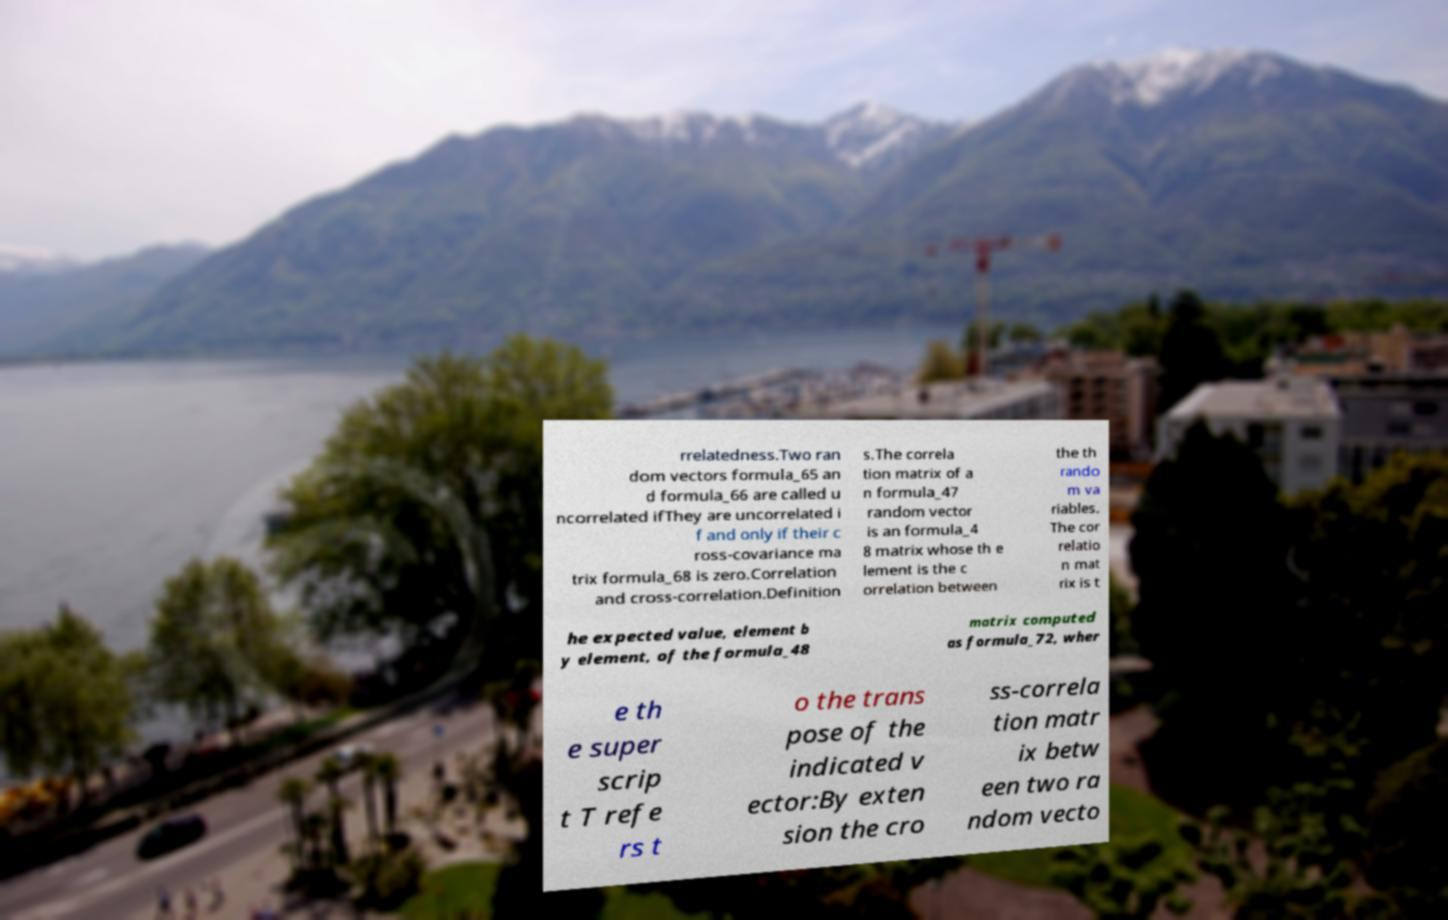Can you read and provide the text displayed in the image?This photo seems to have some interesting text. Can you extract and type it out for me? rrelatedness.Two ran dom vectors formula_65 an d formula_66 are called u ncorrelated ifThey are uncorrelated i f and only if their c ross-covariance ma trix formula_68 is zero.Correlation and cross-correlation.Definition s.The correla tion matrix of a n formula_47 random vector is an formula_4 8 matrix whose th e lement is the c orrelation between the th rando m va riables. The cor relatio n mat rix is t he expected value, element b y element, of the formula_48 matrix computed as formula_72, wher e th e super scrip t T refe rs t o the trans pose of the indicated v ector:By exten sion the cro ss-correla tion matr ix betw een two ra ndom vecto 